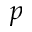<formula> <loc_0><loc_0><loc_500><loc_500>p</formula> 